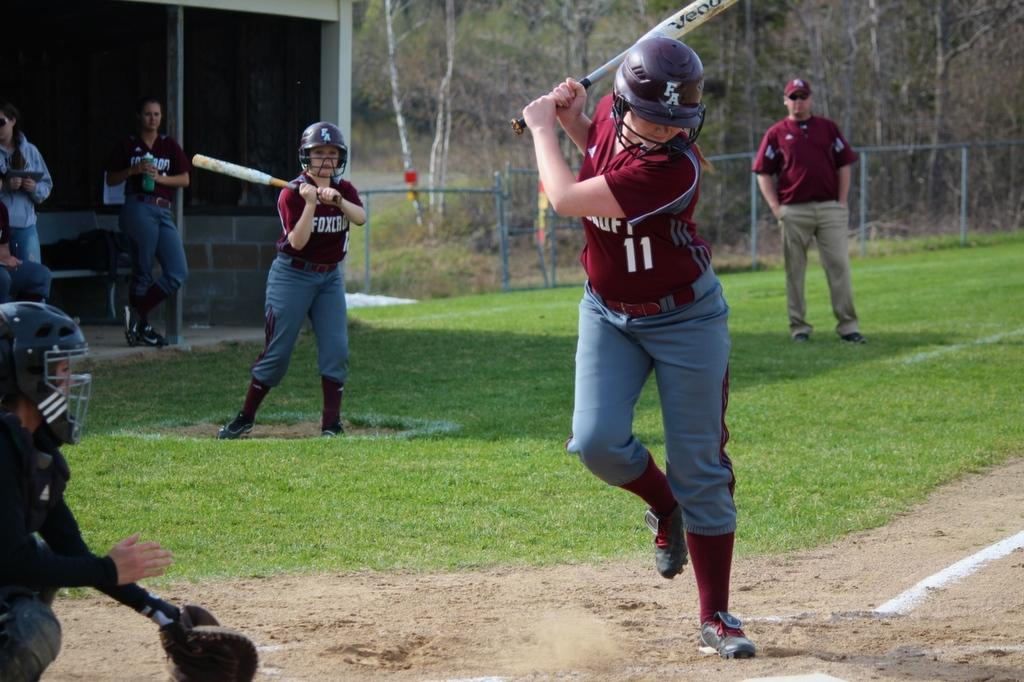<image>
Present a compact description of the photo's key features. a person wearing the number 11 getting ready to swing 